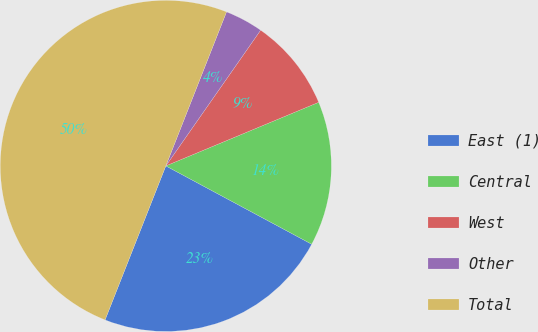Convert chart. <chart><loc_0><loc_0><loc_500><loc_500><pie_chart><fcel>East (1)<fcel>Central<fcel>West<fcel>Other<fcel>Total<nl><fcel>23.14%<fcel>14.12%<fcel>9.02%<fcel>3.73%<fcel>50.0%<nl></chart> 